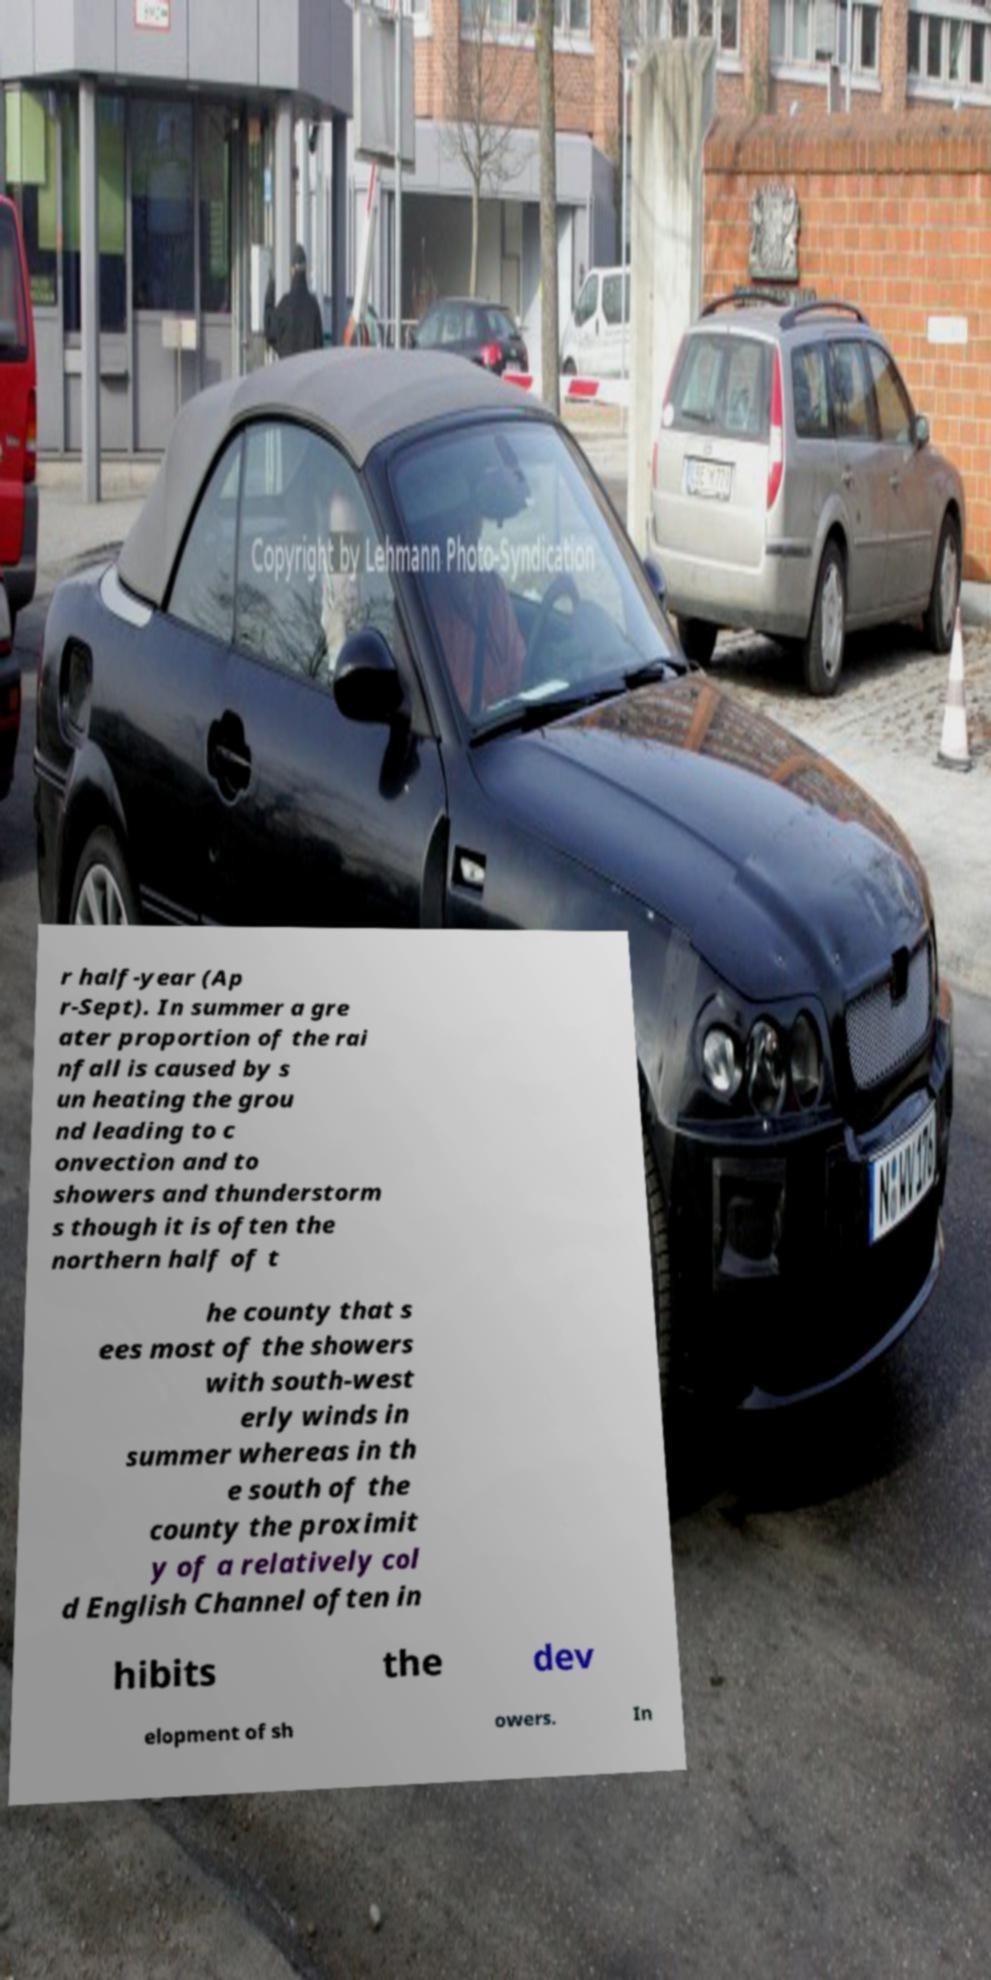For documentation purposes, I need the text within this image transcribed. Could you provide that? r half-year (Ap r-Sept). In summer a gre ater proportion of the rai nfall is caused by s un heating the grou nd leading to c onvection and to showers and thunderstorm s though it is often the northern half of t he county that s ees most of the showers with south-west erly winds in summer whereas in th e south of the county the proximit y of a relatively col d English Channel often in hibits the dev elopment of sh owers. In 